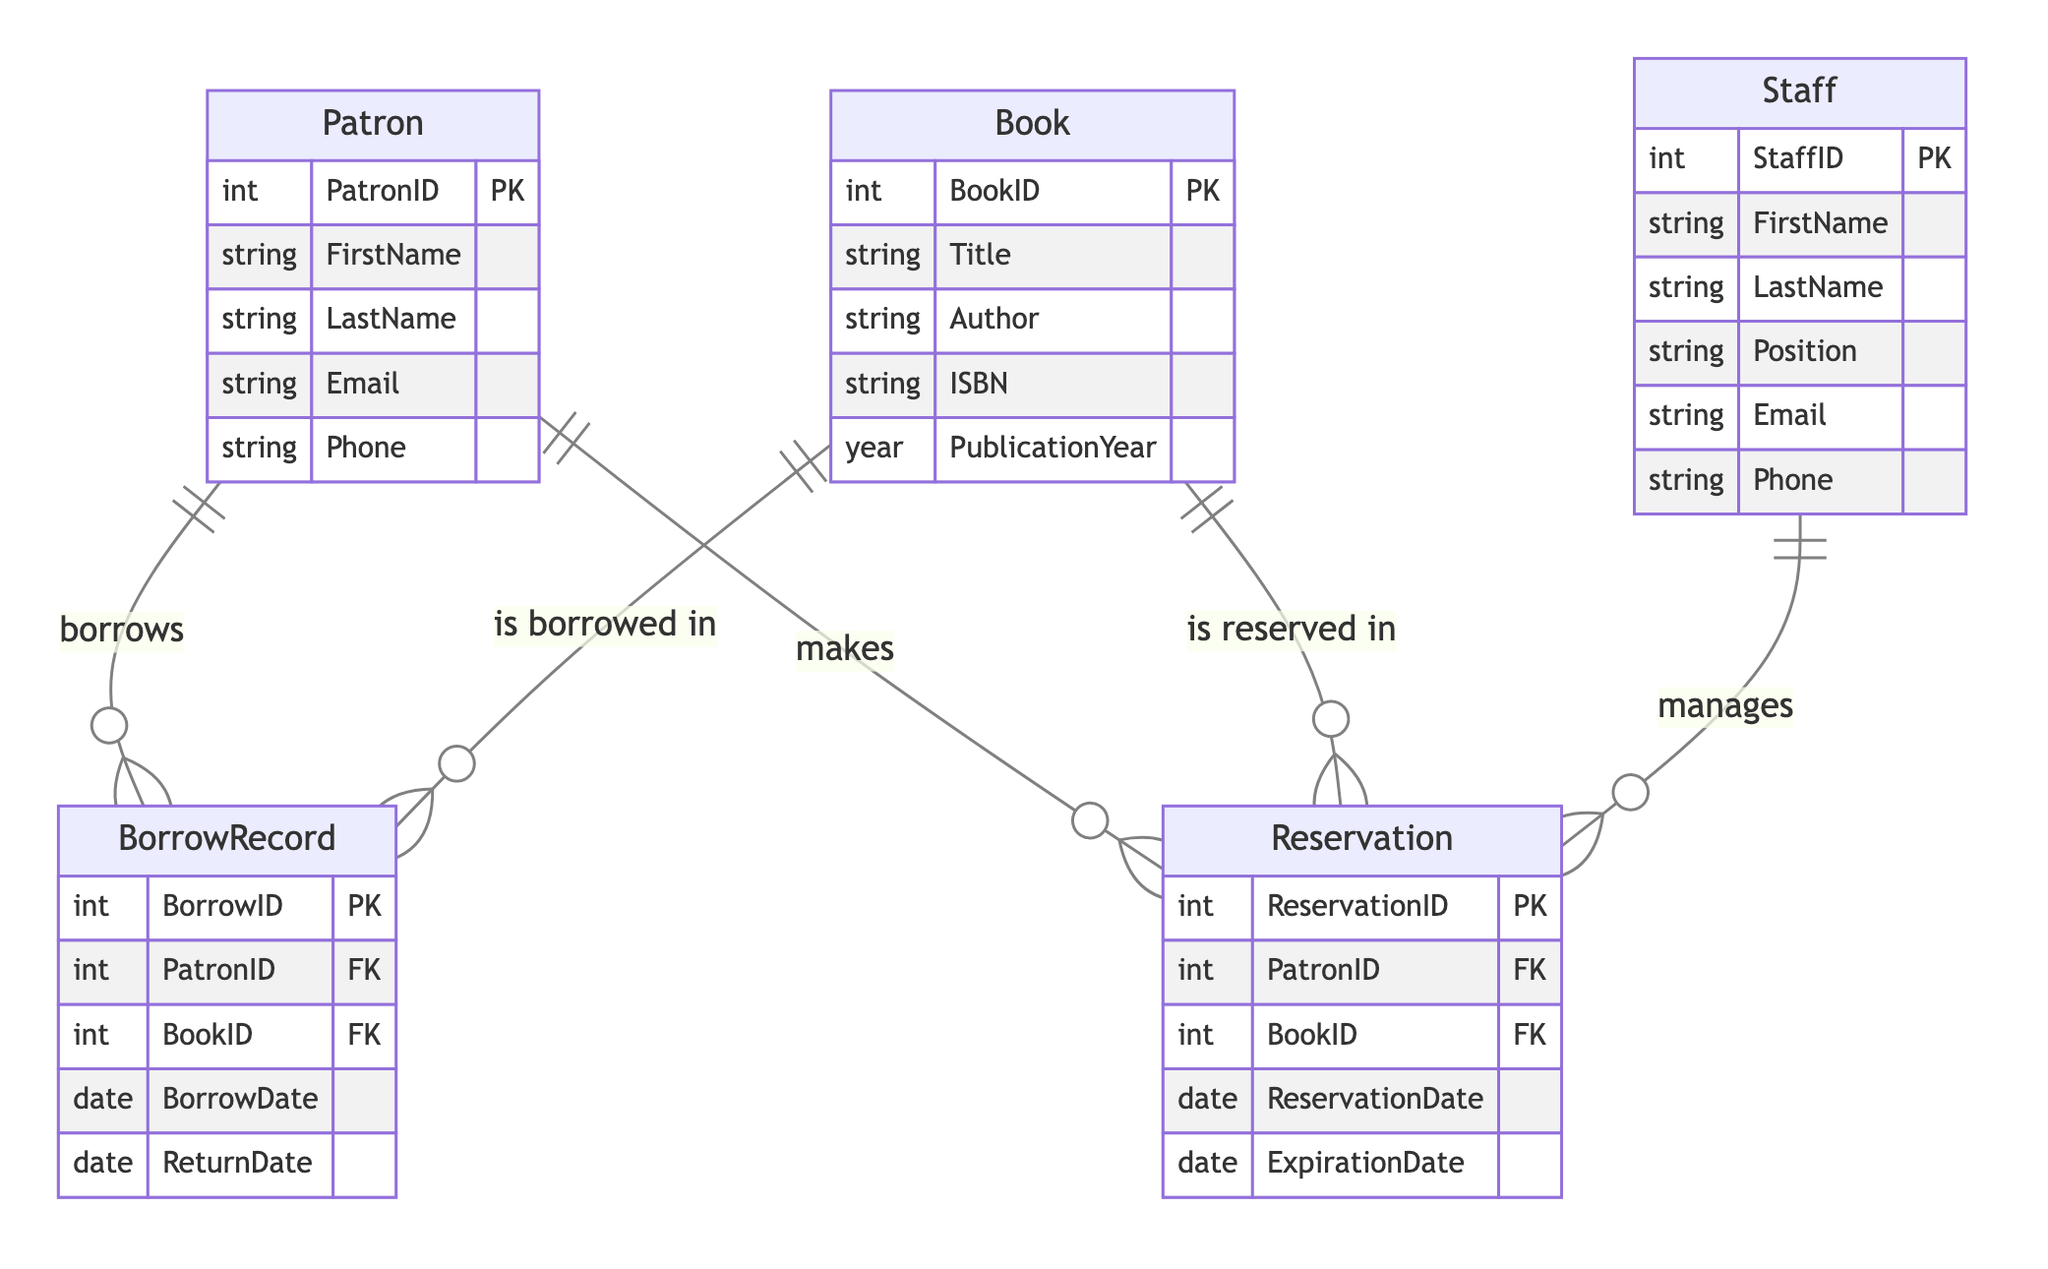What entities are represented in the diagram? The diagram includes the entities Patron, Staff, Book, BorrowRecord, and Reservation. Each of these has its own set of attributes which are specified.
Answer: Patron, Staff, Book, BorrowRecord, Reservation How many attributes does the Patron entity have? The Patron entity has five attributes: PatronID, FirstName, LastName, Email, and Phone. Counting these gives a total of five attributes in the entity.
Answer: Five What is the relationship type between Patron and Book? The relationship between Patron and Book is two-fold: Patron borrows Book (indicated by BorrowRecord) and Patron reserves Book (indicated by Reservation). Therefore, there are two distinct relationships.
Answer: Two What is the primary key of the BorrowRecord entity? The primary key of the BorrowRecord entity is BorrowID, which uniquely identifies each borrowing record.
Answer: BorrowID Which entity manages the Reservation records? The Staff entity is responsible for managing the Reservation records, as indicated by the relationship description in the diagram.
Answer: Staff What attribute connects BorrowRecord to Patron? The attribute that connects BorrowRecord to Patron is PatronID, which serves as a foreign key in the BorrowRecord entity to reference the Patron who borrowed the book.
Answer: PatronID How many entities have a direct relationship with Reservation? The Reservation entity has direct relationships with two entities: Patron (who makes the reservation) and Staff (who manages the reservations). Counting these gives a total of two entities.
Answer: Two What is the role of Book in the borrowing process? The Book entity plays the role of the item that is borrowed by a Patron as indicated by the BorrowRecord entity, which tracks each borrowing instance.
Answer: Is borrowed in How many relationships involve the Staff entity? The Staff entity is involved in one relationship, which is with Reservation, where staff members manage reservations made by patrons. Therefore, there is only one relationship involving Staff.
Answer: One 